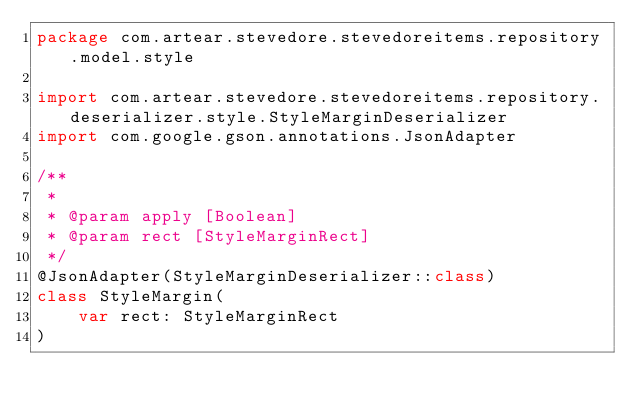<code> <loc_0><loc_0><loc_500><loc_500><_Kotlin_>package com.artear.stevedore.stevedoreitems.repository.model.style

import com.artear.stevedore.stevedoreitems.repository.deserializer.style.StyleMarginDeserializer
import com.google.gson.annotations.JsonAdapter

/**
 *
 * @param apply [Boolean]
 * @param rect [StyleMarginRect]
 */
@JsonAdapter(StyleMarginDeserializer::class)
class StyleMargin(
    var rect: StyleMarginRect
)
</code> 